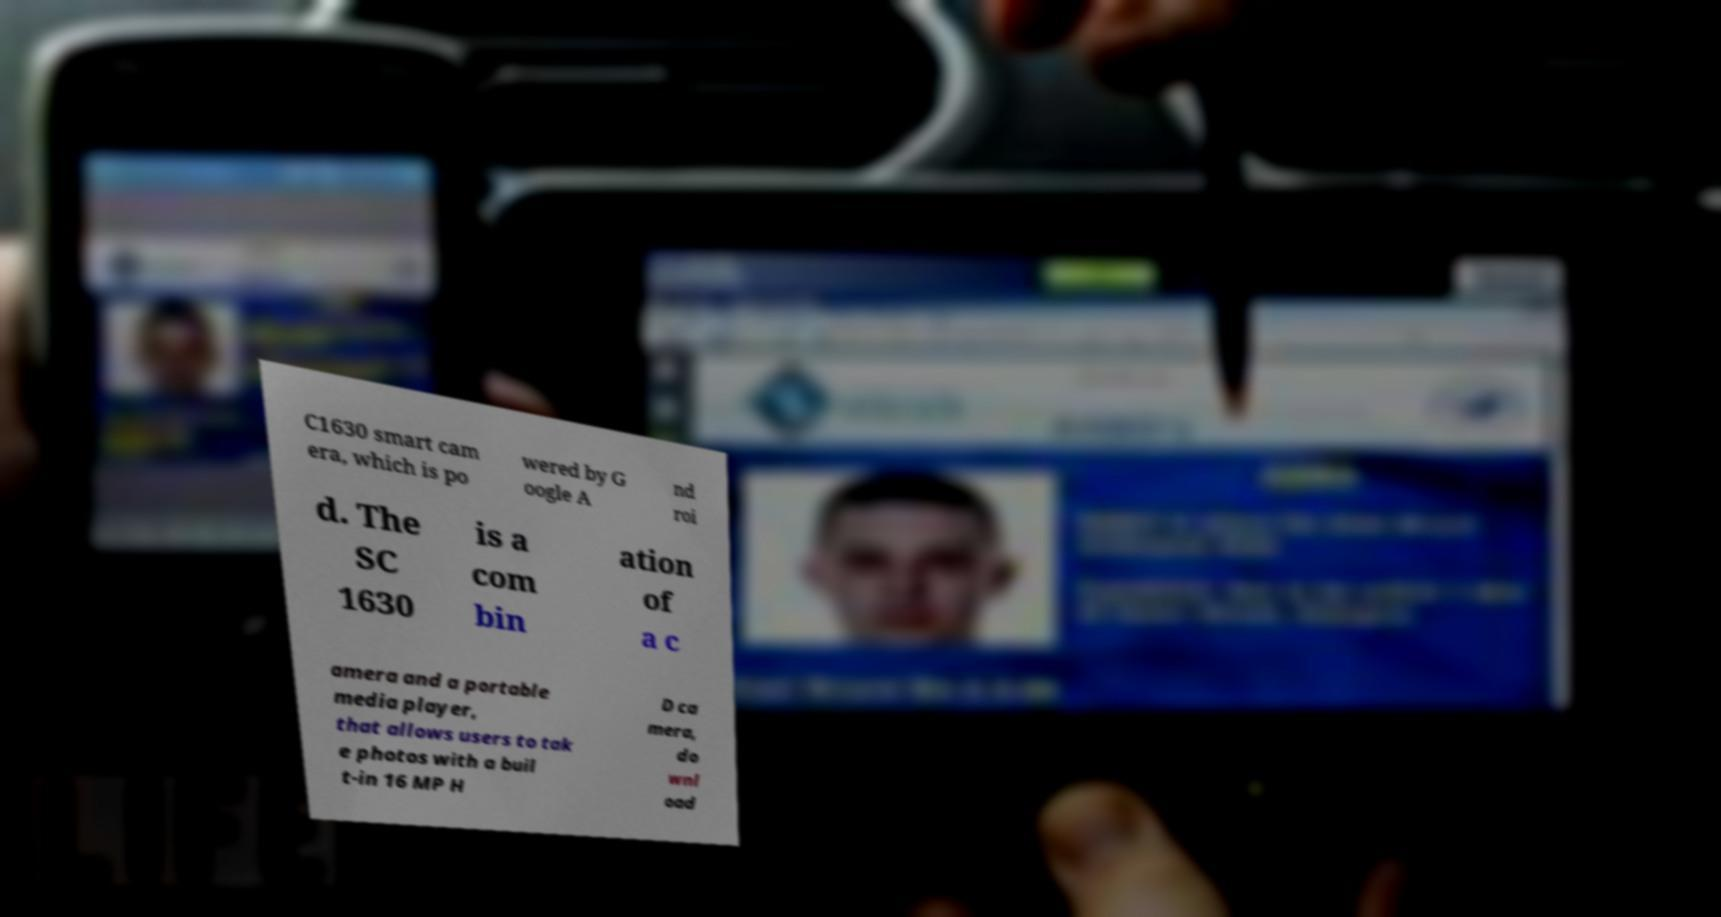Could you extract and type out the text from this image? C1630 smart cam era, which is po wered by G oogle A nd roi d. The SC 1630 is a com bin ation of a c amera and a portable media player, that allows users to tak e photos with a buil t-in 16 MP H D ca mera, do wnl oad 